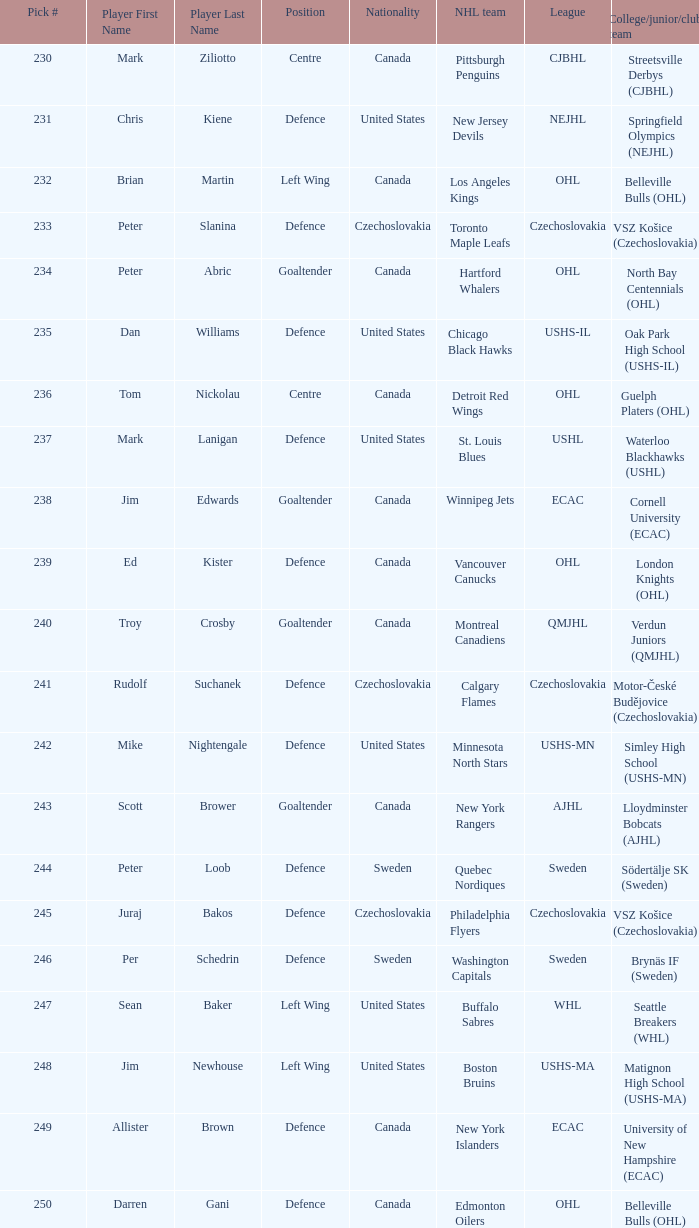List the players for team brynäs if (sweden). Per Schedrin. 